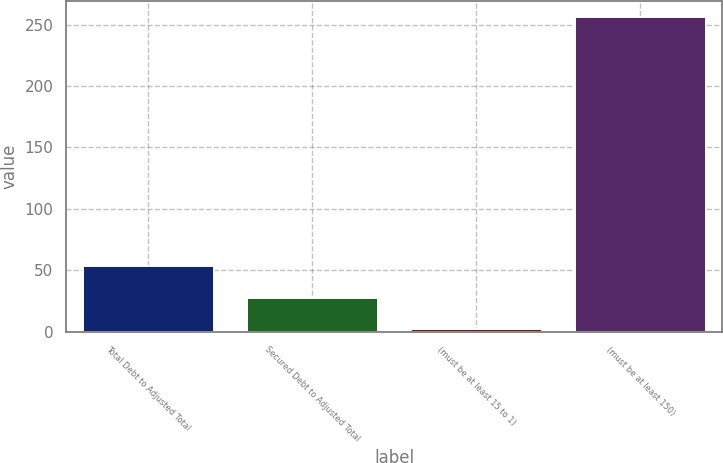<chart> <loc_0><loc_0><loc_500><loc_500><bar_chart><fcel>Total Debt to Adjusted Total<fcel>Secured Debt to Adjusted Total<fcel>(must be at least 15 to 1)<fcel>(must be at least 150)<nl><fcel>53.16<fcel>27.81<fcel>2.46<fcel>256<nl></chart> 